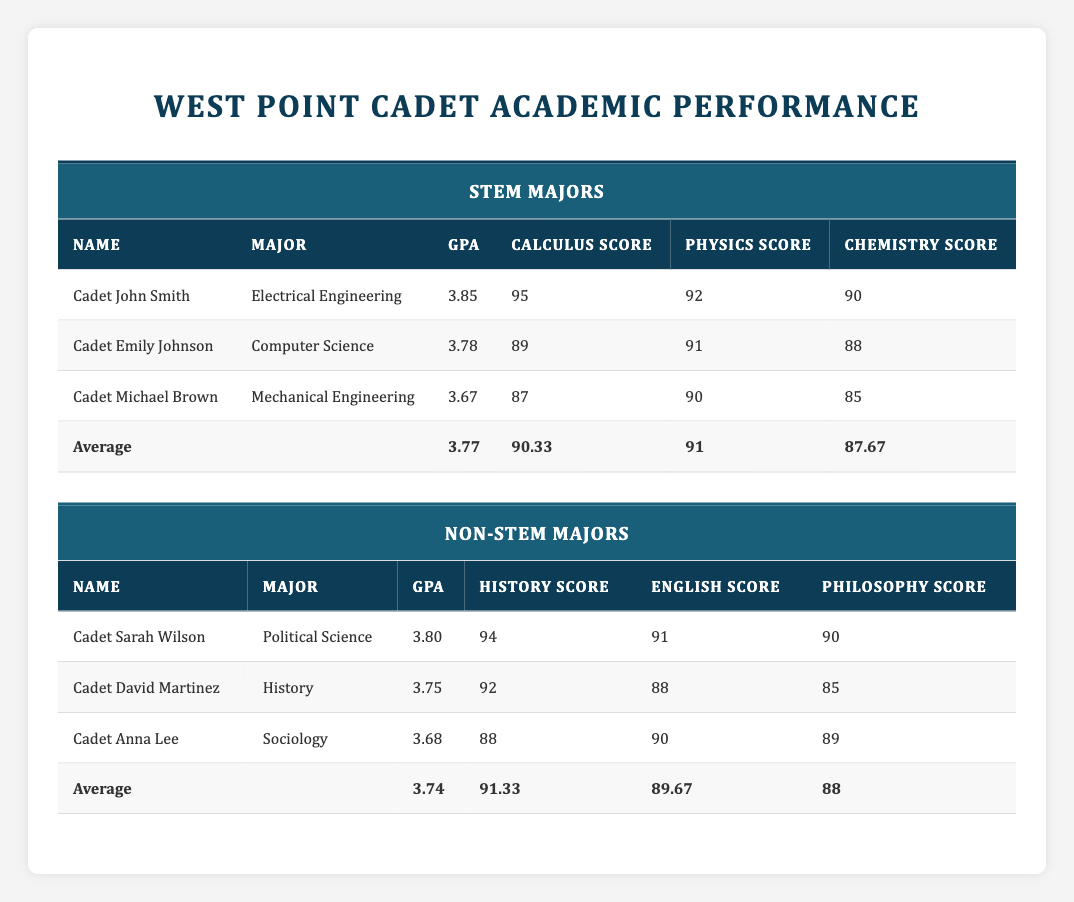What is the average GPA of cadets majoring in STEM? The average GPA for STEM majors can be found in the table under the "STEM Majors" section. It states that the average GPA is 3.77.
Answer: 3.77 Which cadet has the highest calculus score among the STEM majors? By reviewing the calculus scores under "STEM Majors," Cadet John Smith has the highest calculus score of 95.
Answer: Cadet John Smith What is the difference in average GPA between STEM and non-STEM majors? The average GPA for STEM majors is 3.77 and for non-STEM majors it is 3.74. To find the difference, subtract the non-STEM average from the STEM average: 3.77 - 3.74 = 0.03.
Answer: 0.03 Do any cadets in non-STEM majors have a GPA above 3.80? Looking at the table under "Non-STEM Majors," Cadet Sarah Wilson has a GPA of 3.80, which is indeed above that threshold. Thus, the answer is yes.
Answer: Yes What is the average history score for non-STEM majors? The average history score is provided in the table under "Non-STEM Majors," where it lists an average of 91.33 for history scores.
Answer: 91.33 Which major has the lowest average chemistry score among STEM cadets? The chemistry scores for the STEM cadets are as follows: John Smith (90), Emily Johnson (88), and Michael Brown (85). The lowest score is 85 from Cadet Michael Brown, indicating his major, Mechanical Engineering, has the lowest average chemistry score.
Answer: Mechanical Engineering What is the highest physics score among non-STEM major cadets? From the "Non-STEM Majors" section, the physics scores listed are not directly provided; however, it's inferred that there are no physics scores listed for non-STEM cadets. Therefore, it is not applicable to compare these.
Answer: Not applicable How many cadets have a GPA below 3.70 in STEM majors? Reviewing the "STEM Majors" data, we note the GPAs: 3.85, 3.78, and 3.67. Only Cadet Michael Brown has a GPA below 3.70. Thus, there is one cadet in this category.
Answer: 1 What is the average score for English among non-STEM major cadets? The table clearly states that the average English score for non-STEM majors is 89.67, which can be found under the respective section.
Answer: 89.67 